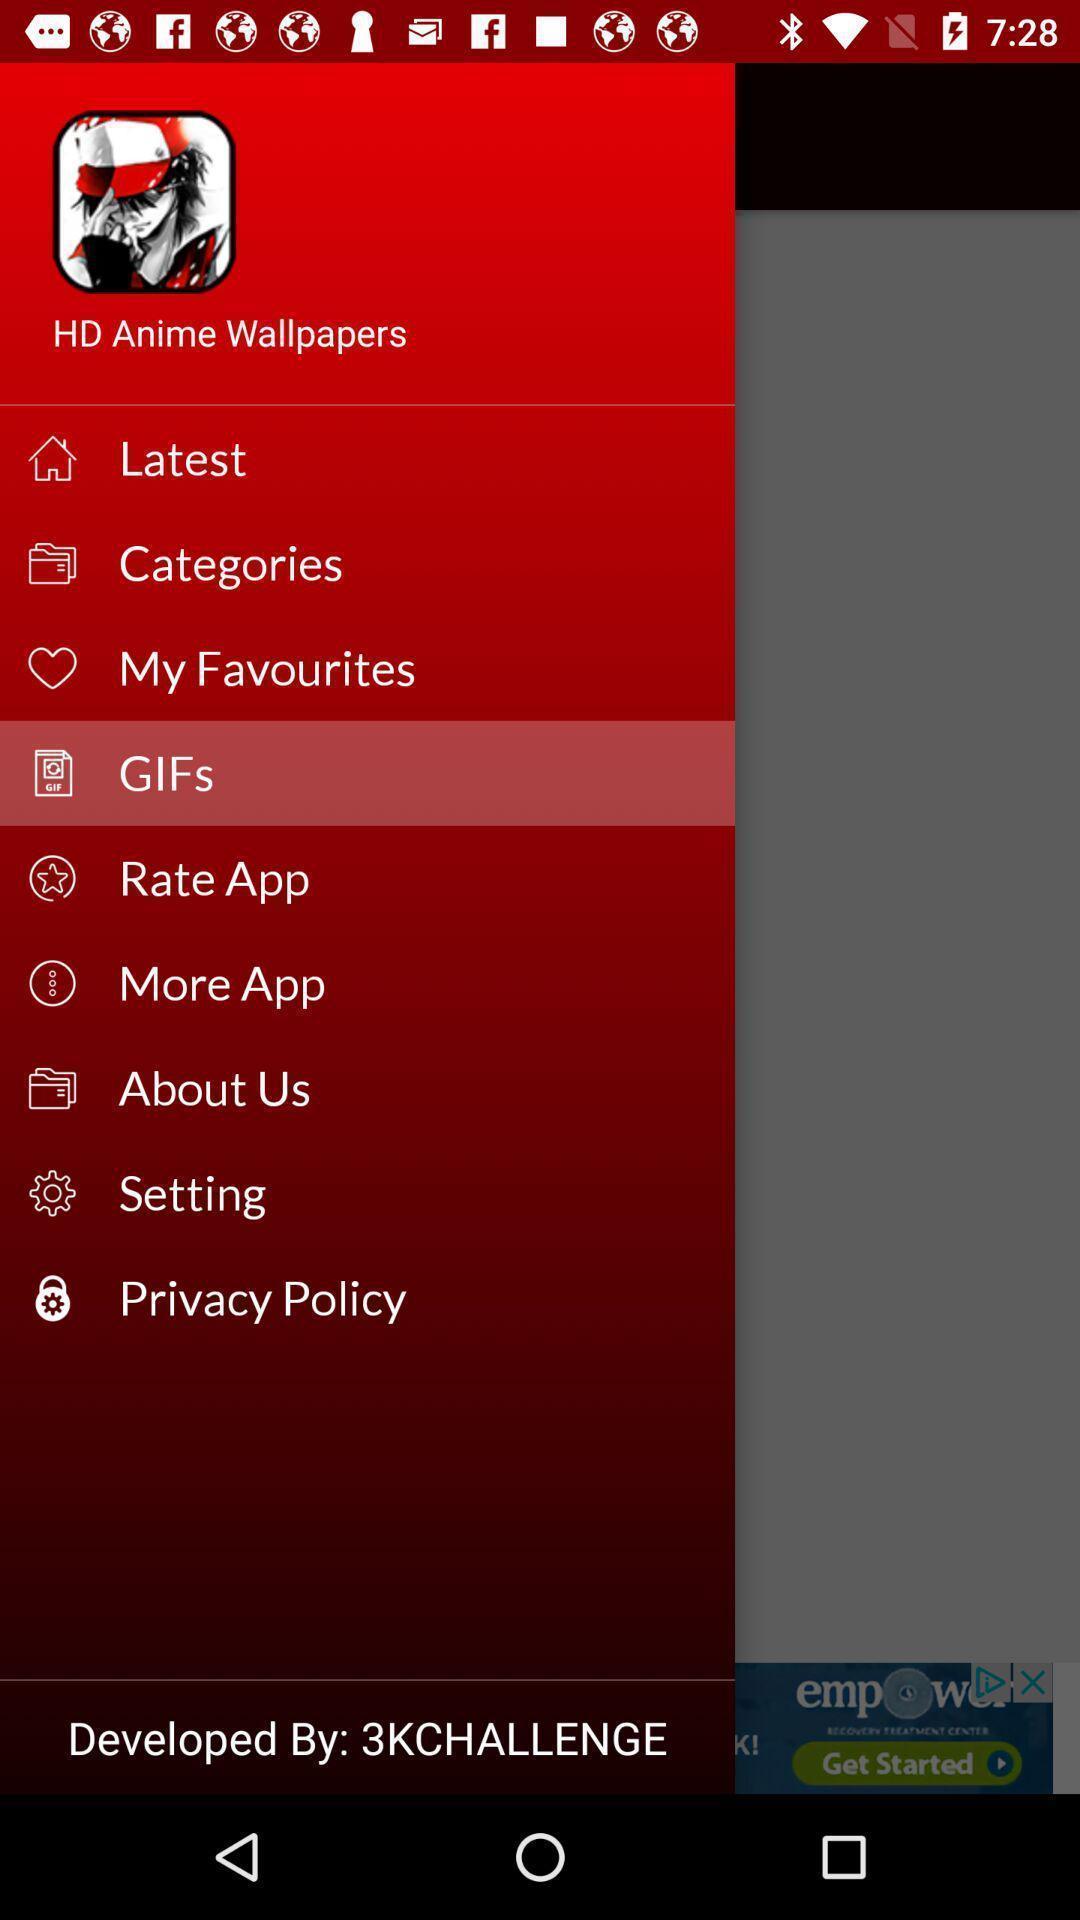Describe the content in this image. Screen displaying the list of features. 